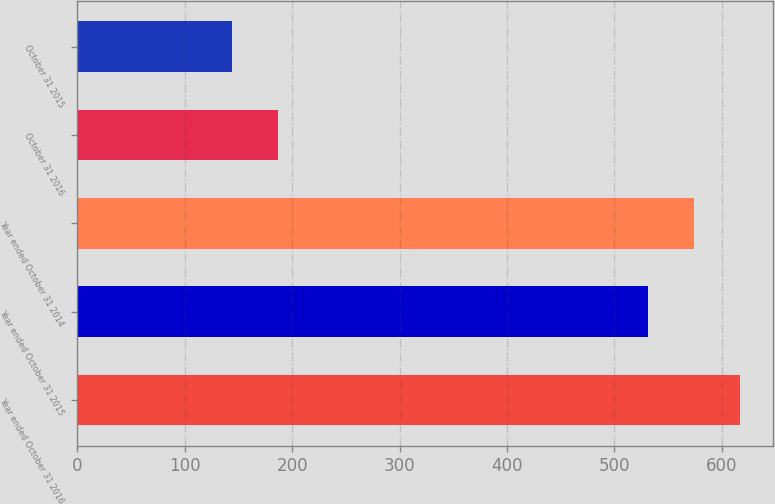Convert chart to OTSL. <chart><loc_0><loc_0><loc_500><loc_500><bar_chart><fcel>Year ended October 31 2016<fcel>Year ended October 31 2015<fcel>Year ended October 31 2014<fcel>October 31 2016<fcel>October 31 2015<nl><fcel>616.6<fcel>531<fcel>573.8<fcel>186.8<fcel>144<nl></chart> 